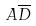Convert formula to latex. <formula><loc_0><loc_0><loc_500><loc_500>A \overline { D }</formula> 